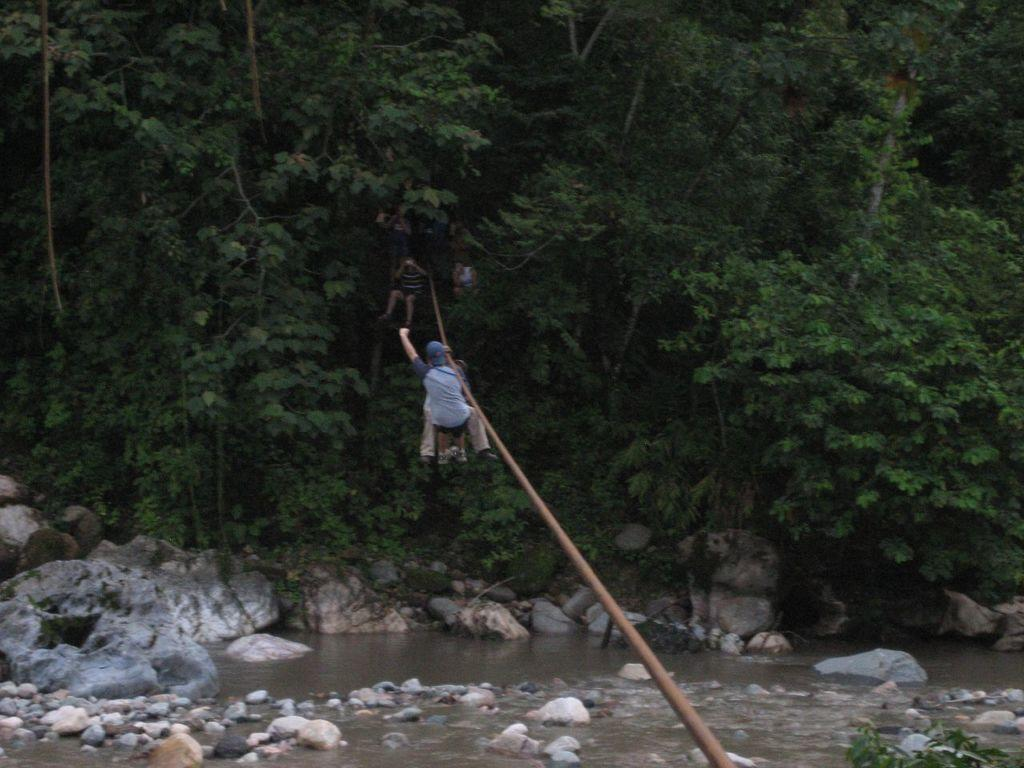What is present in the image that people can hold onto? There is a rope in the image that people are hanging onto. What is at the bottom of the image? There is water at the bottom of the image. What can be seen in the image besides the rope and water? There are rocks in the image. What is visible in the background of the image? There are trees in the background of the image. What type of horn can be heard in the image? There is no horn present in the image, and therefore no sound can be heard. 